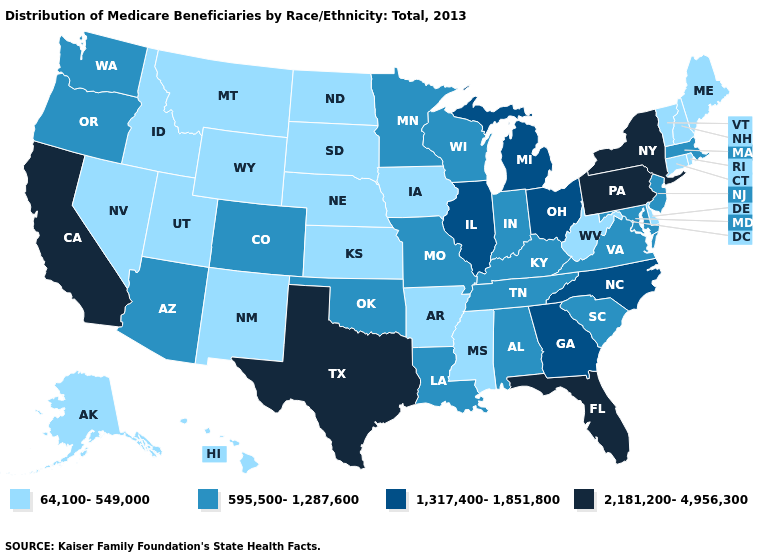Which states have the lowest value in the USA?
Short answer required. Alaska, Arkansas, Connecticut, Delaware, Hawaii, Idaho, Iowa, Kansas, Maine, Mississippi, Montana, Nebraska, Nevada, New Hampshire, New Mexico, North Dakota, Rhode Island, South Dakota, Utah, Vermont, West Virginia, Wyoming. Which states have the lowest value in the South?
Keep it brief. Arkansas, Delaware, Mississippi, West Virginia. Does New Mexico have a higher value than Virginia?
Be succinct. No. What is the value of Utah?
Concise answer only. 64,100-549,000. Does the first symbol in the legend represent the smallest category?
Quick response, please. Yes. Name the states that have a value in the range 595,500-1,287,600?
Quick response, please. Alabama, Arizona, Colorado, Indiana, Kentucky, Louisiana, Maryland, Massachusetts, Minnesota, Missouri, New Jersey, Oklahoma, Oregon, South Carolina, Tennessee, Virginia, Washington, Wisconsin. Name the states that have a value in the range 2,181,200-4,956,300?
Keep it brief. California, Florida, New York, Pennsylvania, Texas. Which states have the lowest value in the USA?
Be succinct. Alaska, Arkansas, Connecticut, Delaware, Hawaii, Idaho, Iowa, Kansas, Maine, Mississippi, Montana, Nebraska, Nevada, New Hampshire, New Mexico, North Dakota, Rhode Island, South Dakota, Utah, Vermont, West Virginia, Wyoming. Does Kansas have the highest value in the USA?
Give a very brief answer. No. What is the highest value in the MidWest ?
Be succinct. 1,317,400-1,851,800. Name the states that have a value in the range 595,500-1,287,600?
Answer briefly. Alabama, Arizona, Colorado, Indiana, Kentucky, Louisiana, Maryland, Massachusetts, Minnesota, Missouri, New Jersey, Oklahoma, Oregon, South Carolina, Tennessee, Virginia, Washington, Wisconsin. What is the lowest value in the Northeast?
Be succinct. 64,100-549,000. Does Wyoming have the same value as Illinois?
Short answer required. No. Does Nevada have a lower value than Utah?
Write a very short answer. No. Among the states that border New Jersey , which have the lowest value?
Short answer required. Delaware. 